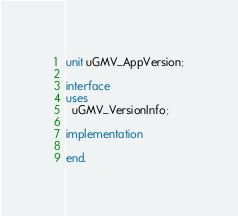Convert code to text. <code><loc_0><loc_0><loc_500><loc_500><_Pascal_>unit uGMV_AppVersion;

interface
uses
  uGMV_VersionInfo;

implementation

end.
</code> 